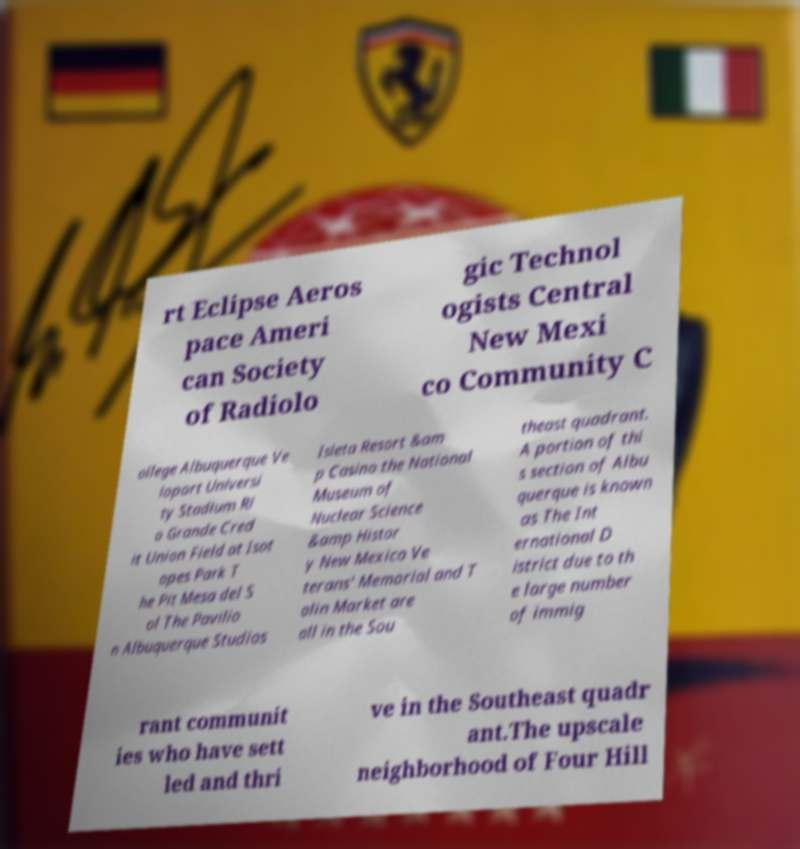Can you accurately transcribe the text from the provided image for me? rt Eclipse Aeros pace Ameri can Society of Radiolo gic Technol ogists Central New Mexi co Community C ollege Albuquerque Ve loport Universi ty Stadium Ri o Grande Cred it Union Field at Isot opes Park T he Pit Mesa del S ol The Pavilio n Albuquerque Studios Isleta Resort &am p Casino the National Museum of Nuclear Science &amp Histor y New Mexico Ve terans' Memorial and T alin Market are all in the Sou theast quadrant. A portion of thi s section of Albu querque is known as The Int ernational D istrict due to th e large number of immig rant communit ies who have sett led and thri ve in the Southeast quadr ant.The upscale neighborhood of Four Hill 